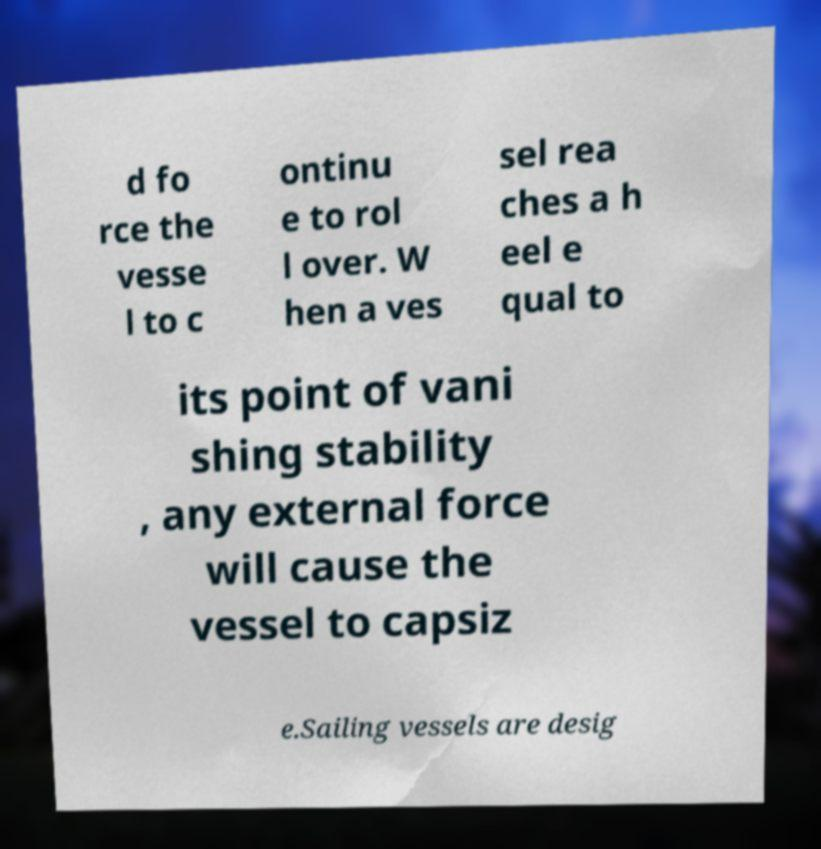Could you extract and type out the text from this image? d fo rce the vesse l to c ontinu e to rol l over. W hen a ves sel rea ches a h eel e qual to its point of vani shing stability , any external force will cause the vessel to capsiz e.Sailing vessels are desig 